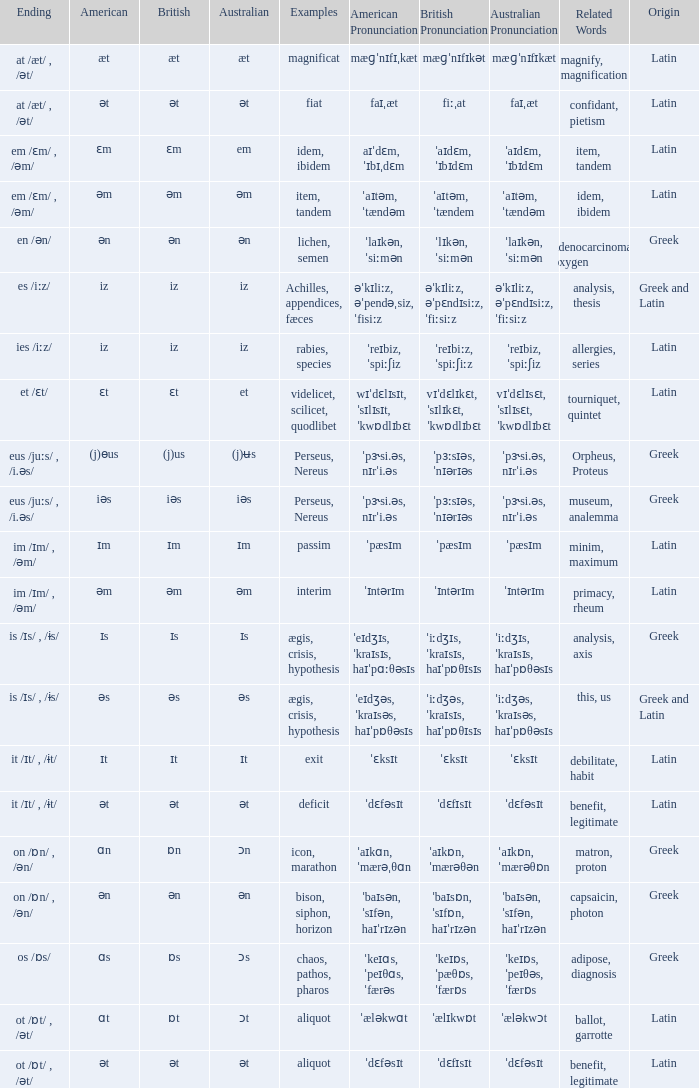Which American has British of ɛm? Ɛm. 